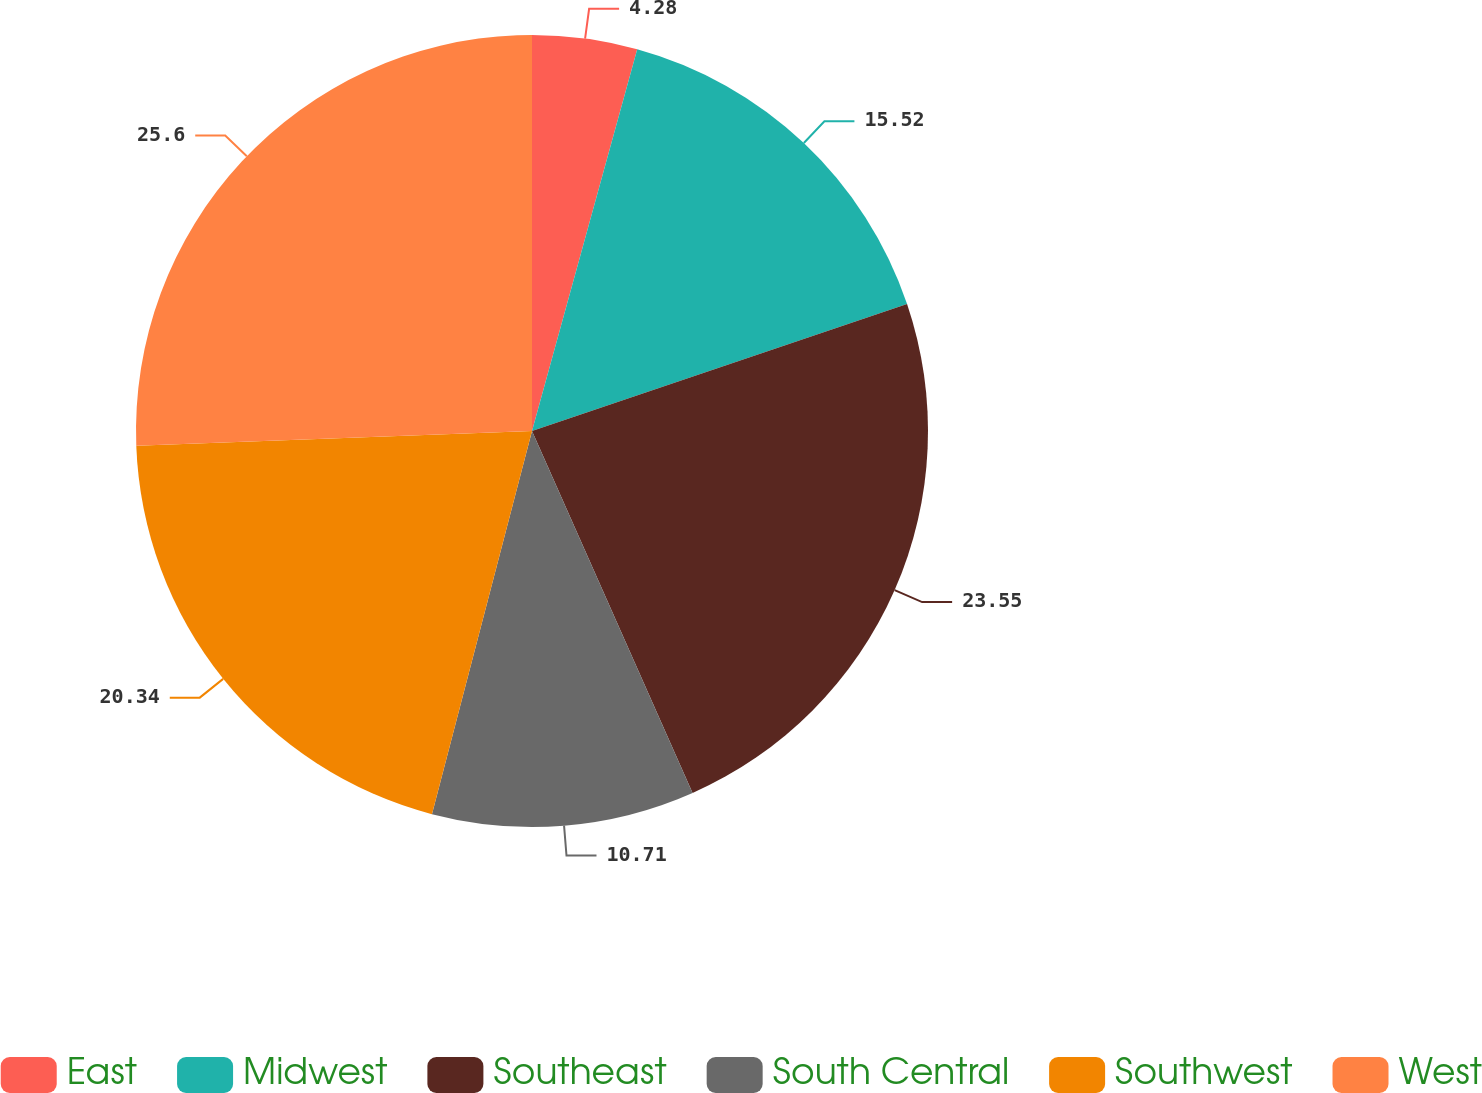<chart> <loc_0><loc_0><loc_500><loc_500><pie_chart><fcel>East<fcel>Midwest<fcel>Southeast<fcel>South Central<fcel>Southwest<fcel>West<nl><fcel>4.28%<fcel>15.52%<fcel>23.55%<fcel>10.71%<fcel>20.34%<fcel>25.59%<nl></chart> 